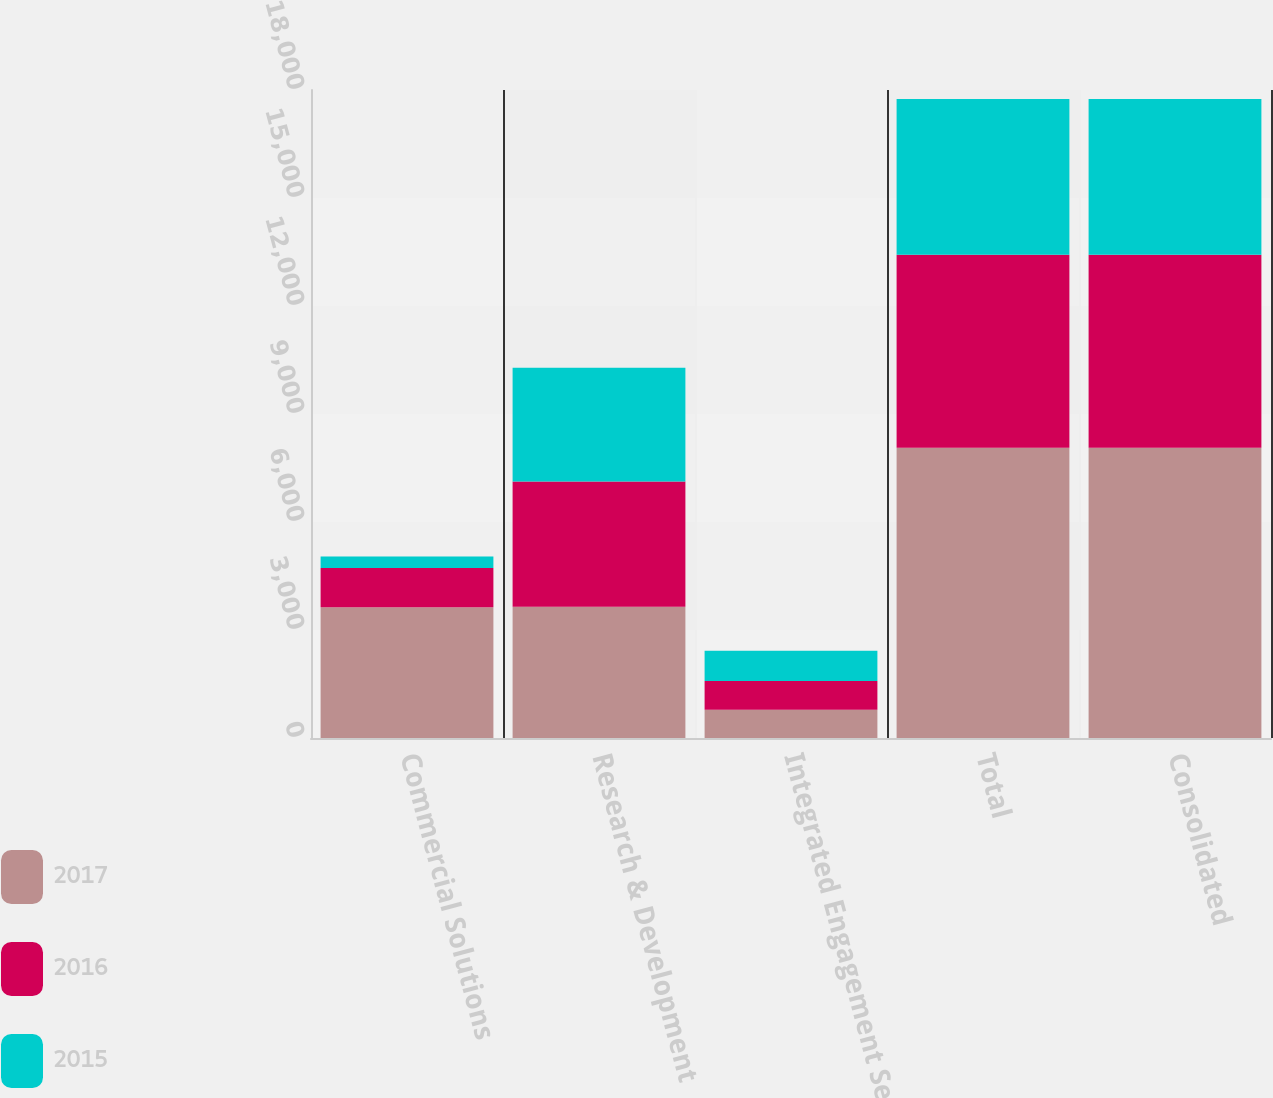Convert chart to OTSL. <chart><loc_0><loc_0><loc_500><loc_500><stacked_bar_chart><ecel><fcel>Commercial Solutions<fcel>Research & Development<fcel>Integrated Engagement Services<fcel>Total<fcel>Consolidated<nl><fcel>2017<fcel>3630<fcel>3647<fcel>783<fcel>8060<fcel>8060<nl><fcel>2016<fcel>1089<fcel>3478<fcel>797<fcel>5364<fcel>5364<nl><fcel>2015<fcel>323<fcel>3159<fcel>844<fcel>4326<fcel>4326<nl></chart> 